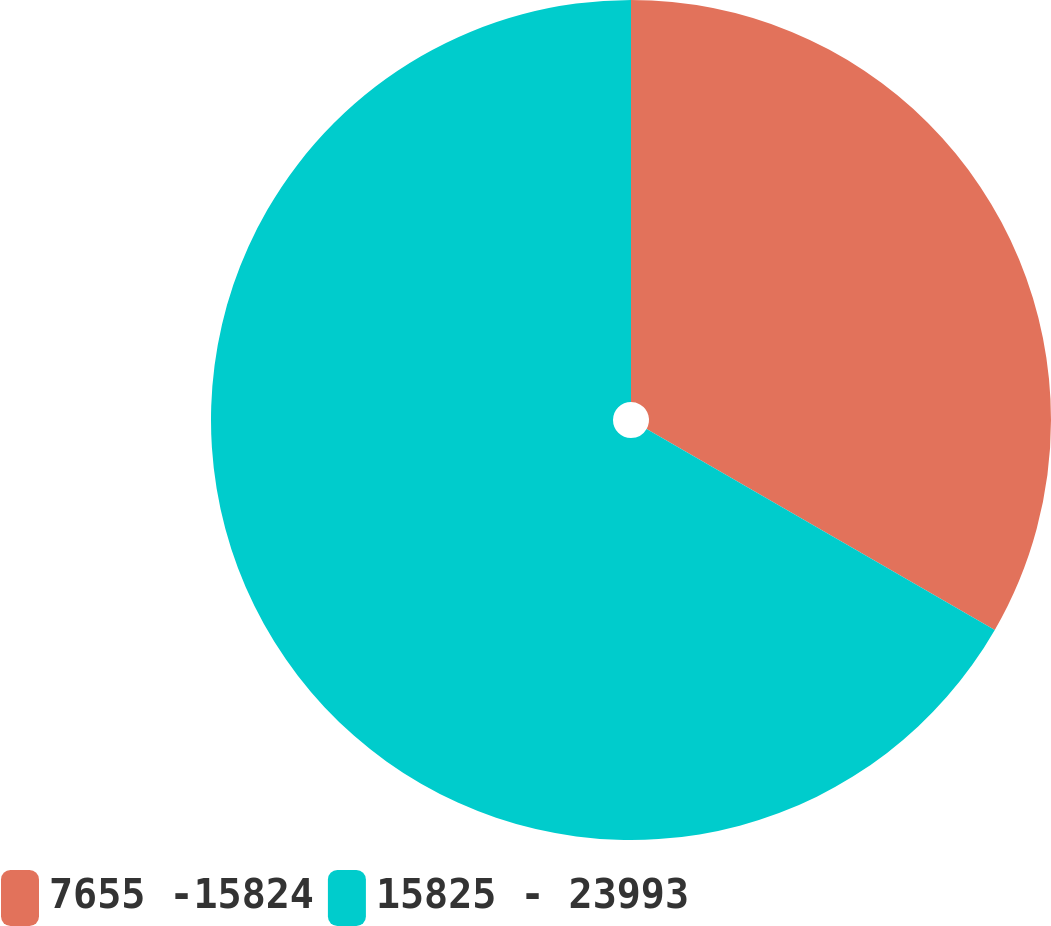<chart> <loc_0><loc_0><loc_500><loc_500><pie_chart><fcel>7655 -15824<fcel>15825 - 23993<nl><fcel>33.33%<fcel>66.67%<nl></chart> 